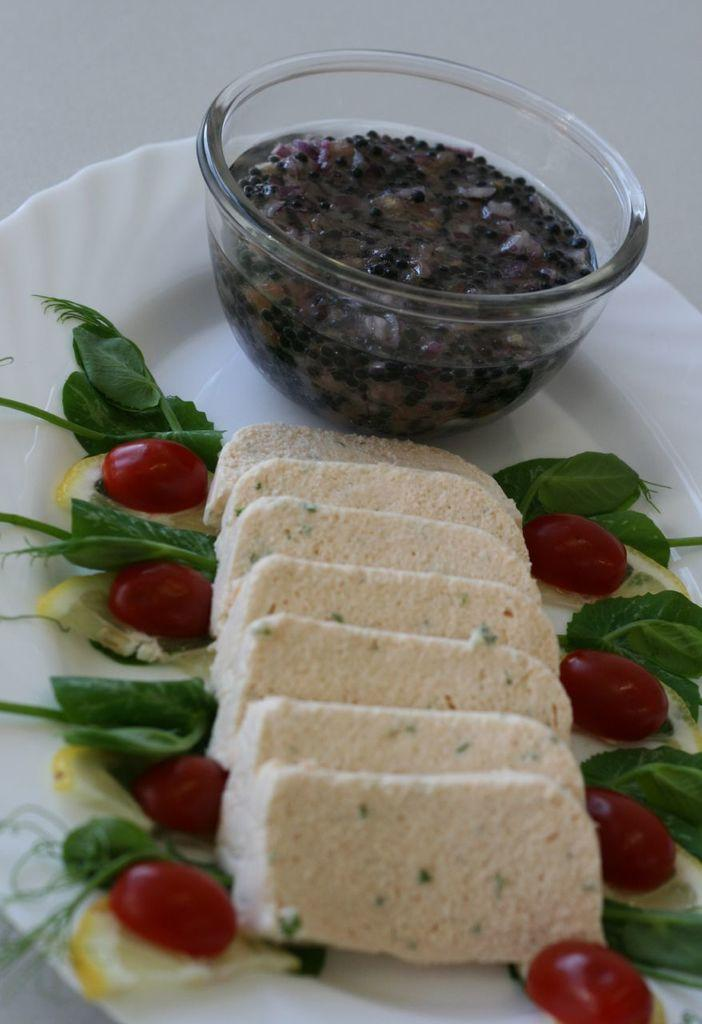What is on the serving plate in the image? The serving plate contains bread slices, lemon wedges, cherry tomatoes, mint leaves, and dill leaves. What else is on the serving plate besides the various items? There is a bowl of dip on the serving plate. How many lamps are on the serving plate in the image? There are no lamps present on the serving plate in the image. What type of shock can be seen on the brothers' faces in the image? There are no brothers or any indication of shock in the image; it only features a serving plate with various food items and a bowl of dip. 